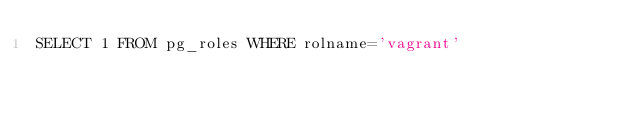<code> <loc_0><loc_0><loc_500><loc_500><_SQL_>SELECT 1 FROM pg_roles WHERE rolname='vagrant'
</code> 